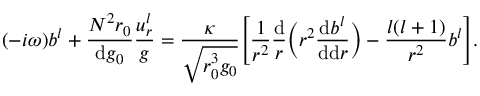Convert formula to latex. <formula><loc_0><loc_0><loc_500><loc_500>( - i \omega ) b ^ { l } + \frac { N ^ { 2 } r _ { 0 } } { d g _ { 0 } } \frac { u _ { r } ^ { l } } { g } = \frac { \kappa } { \sqrt { r _ { 0 } ^ { 3 } g _ { 0 } } } \left [ \frac { 1 } { r ^ { 2 } } \frac { d } { r } \left ( r ^ { 2 } \frac { d b ^ { l } } { d d r } \right ) - \frac { l ( l + 1 ) } { r ^ { 2 } } b ^ { l } \right ] .</formula> 